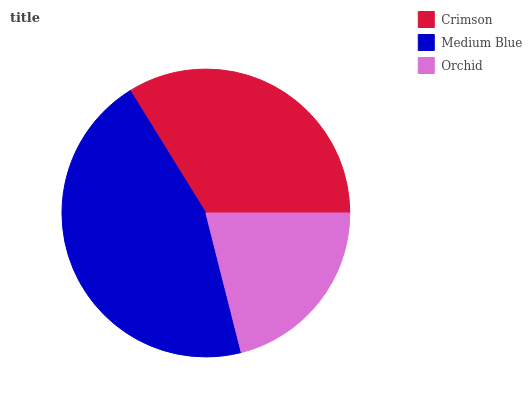Is Orchid the minimum?
Answer yes or no. Yes. Is Medium Blue the maximum?
Answer yes or no. Yes. Is Medium Blue the minimum?
Answer yes or no. No. Is Orchid the maximum?
Answer yes or no. No. Is Medium Blue greater than Orchid?
Answer yes or no. Yes. Is Orchid less than Medium Blue?
Answer yes or no. Yes. Is Orchid greater than Medium Blue?
Answer yes or no. No. Is Medium Blue less than Orchid?
Answer yes or no. No. Is Crimson the high median?
Answer yes or no. Yes. Is Crimson the low median?
Answer yes or no. Yes. Is Orchid the high median?
Answer yes or no. No. Is Medium Blue the low median?
Answer yes or no. No. 